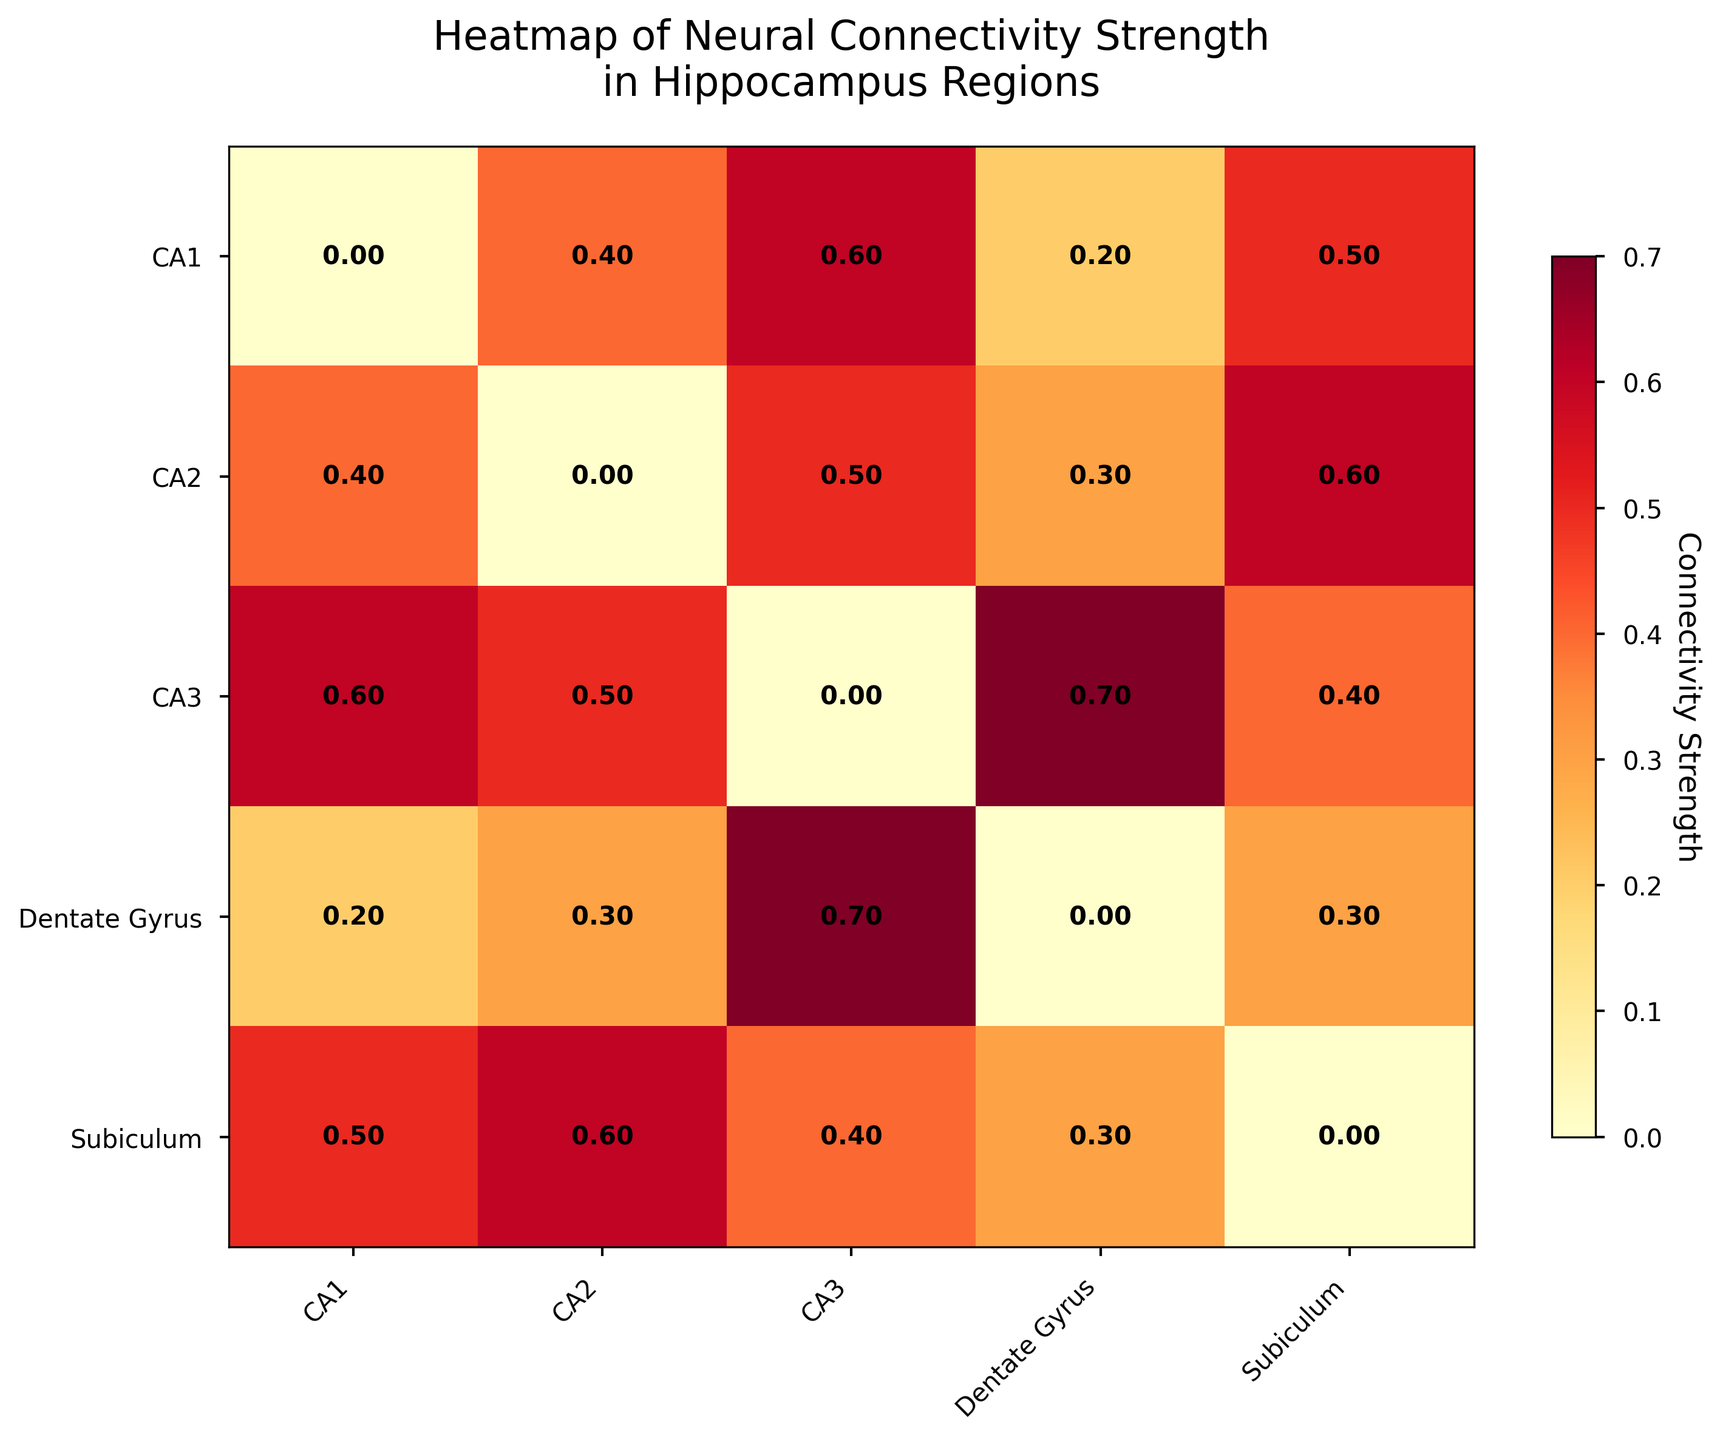What is the title of the heatmap? The title of a heatmap is usually written at the top of the figure. In this case, it reads "Heatmap of Neural Connectivity Strength in Hippocampus Regions."
Answer: Heatmap of Neural Connectivity Strength in Hippocampus Regions What regions are on the x-axis and y-axis of the heatmap? Both the x-axis and y-axis have regions of the hippocampus labeled as CA1, CA2, CA3, Dentate Gyrus, and Subiculum.
Answer: CA1, CA2, CA3, Dentate Gyrus, Subiculum What is the connectivity strength between CA1 and CA3? Locate the intersection of the row labeled CA1 and the column labeled CA3. The value at this intersection is 0.6.
Answer: 0.6 Which region has the highest connectivity strength with CA2? Find the row labeled CA2 and look for the highest value. The highest value in this row is 0.6 at the column labeled Subiculum.
Answer: Subiculum What is the average connectivity strength of the Subiculum with all other regions? Sum the connectivity strengths in the row for Subiculum (0.5, 0.6, 0.4, 0.3) and divide by the number of regions (4). The sum is 1.8, so 1.8/4 equals 0.45.
Answer: 0.45 Is the connectivity strength from CA3 to Dentate Gyrus greater than from Dentate Gyrus to CA3? Compare the value at the intersection of the CA3 row and the Dentate Gyrus column (0.7) with the value at the intersection of the Dentate Gyrus row and the CA3 column (0.7). Both values are the same.
Answer: No Which pair of regions has a bidirectional connectivity strength of 0.4? Find a symmetric pair (same value at [i][j] and [j][i]) where both values are 0.4. CA1 and CA3 fit this criterion with 0.4 in (CA1, CA3) and (CA3, CA1).
Answer: CA1 and CA3 Which region has the lowest average connectivity strength with other regions? Calculate the average connectivity strength for each region by summing the values in each row and dividing by the number of regions (4), then find the lowest average. The averages are: CA1 (0.425), CA2 (0.45), CA3 (0.55), Dentate Gyrus (0.375), Subiculum (0.45). Dentate Gyrus has the lowest average.
Answer: Dentate Gyrus What is the sum of the connectivity strengths for the CA2 row? Add the values in the CA2 row: 0.4 + 0.5 + 0.3 + 0.6, which equals 1.8.
Answer: 1.8 Which region has the equal connectivity strength of 0.3 with two other regions? Look for a row with exactly two values of 0.3. The Dentate Gyrus has connectivity strengths of 0.3 with CA2 and Subiculum.
Answer: Dentate Gyrus 